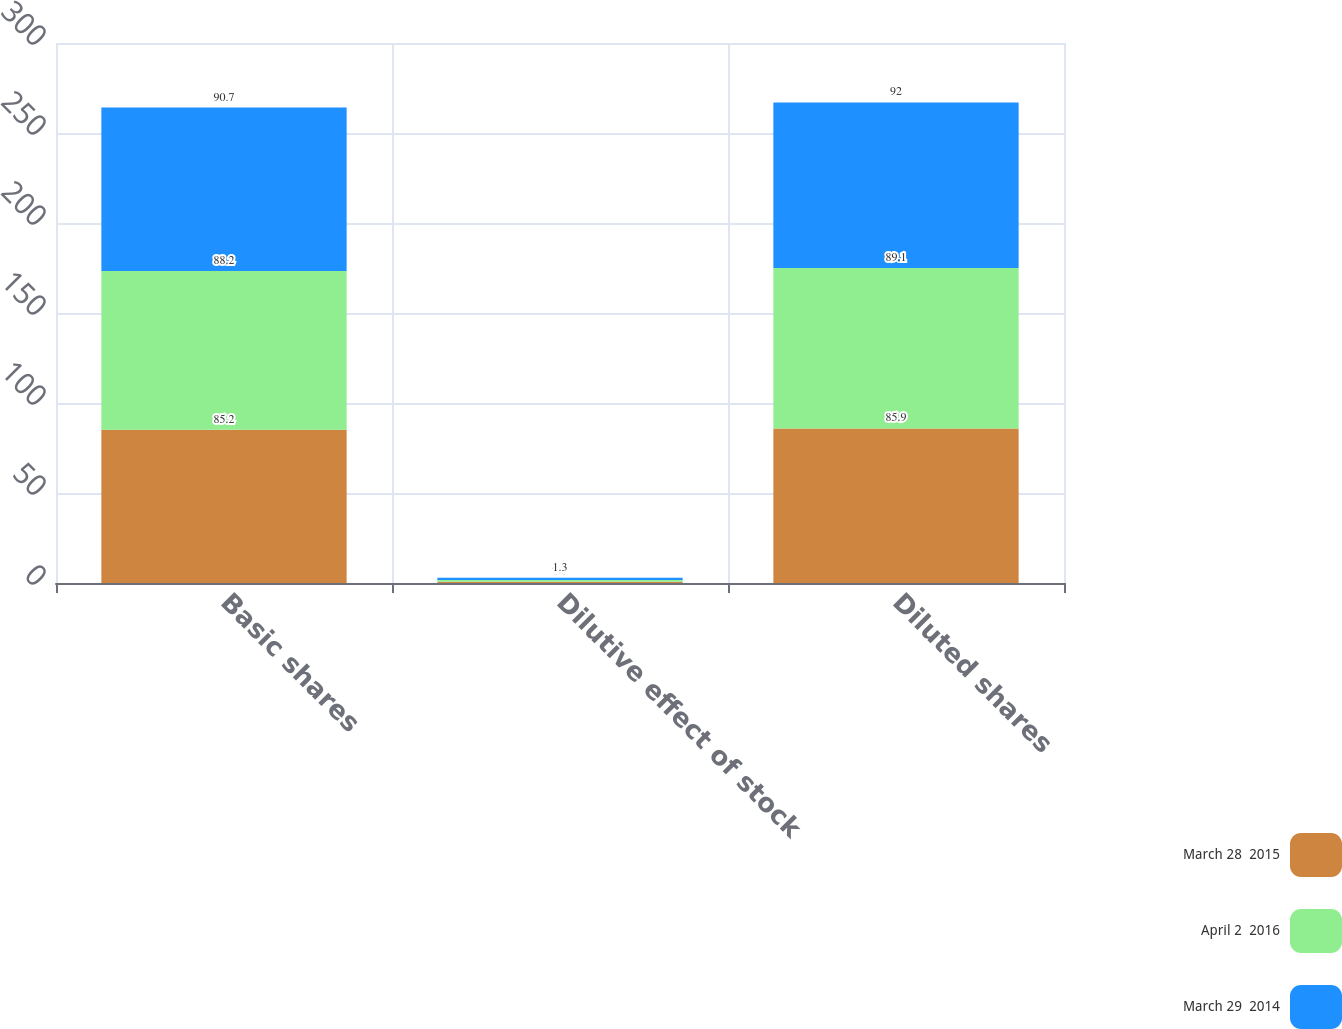<chart> <loc_0><loc_0><loc_500><loc_500><stacked_bar_chart><ecel><fcel>Basic shares<fcel>Dilutive effect of stock<fcel>Diluted shares<nl><fcel>March 28  2015<fcel>85.2<fcel>0.7<fcel>85.9<nl><fcel>April 2  2016<fcel>88.2<fcel>0.9<fcel>89.1<nl><fcel>March 29  2014<fcel>90.7<fcel>1.3<fcel>92<nl></chart> 